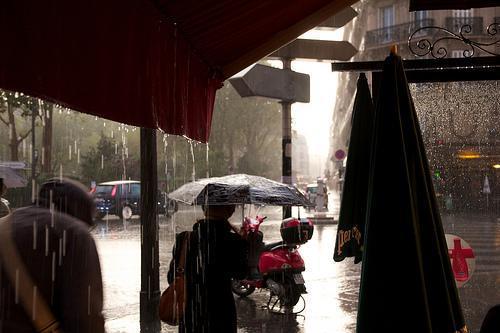How many umbrellas are in the photo?
Give a very brief answer. 1. How many people are in the photo?
Give a very brief answer. 2. 